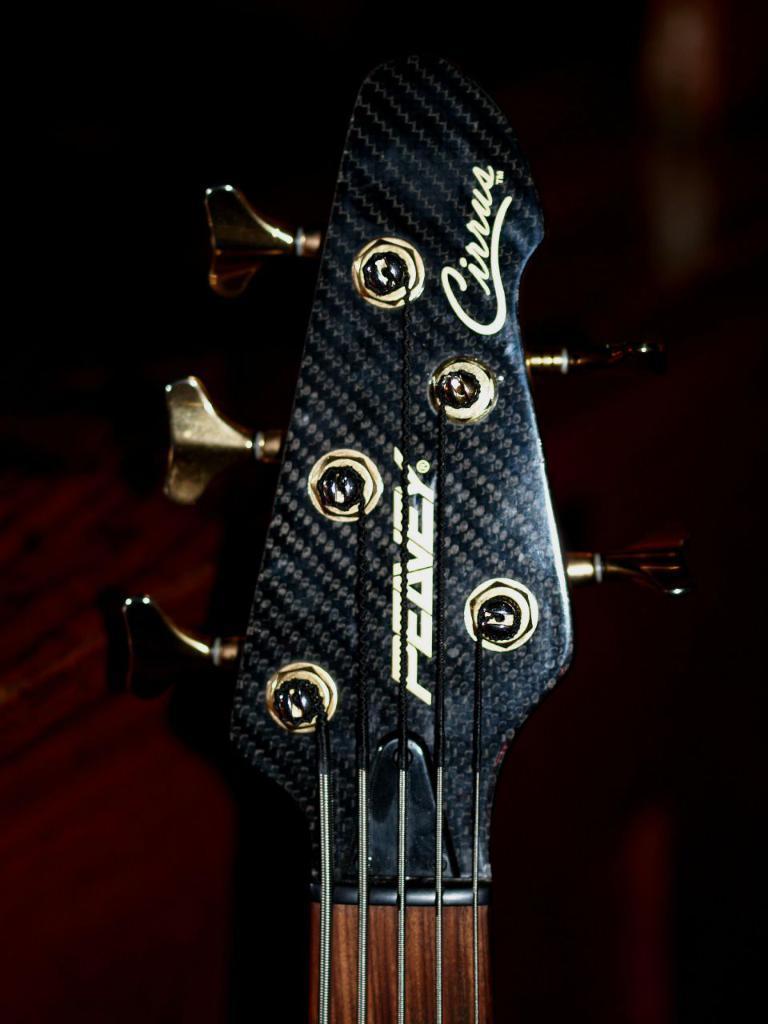Can you describe this image briefly? In this picture we can see a guitar and its keys present 